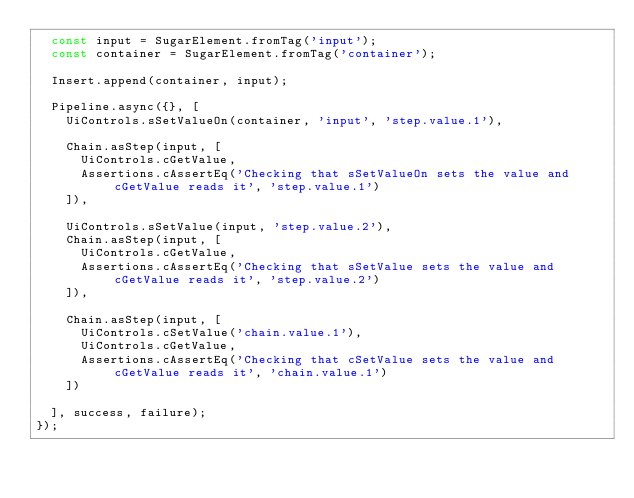Convert code to text. <code><loc_0><loc_0><loc_500><loc_500><_TypeScript_>  const input = SugarElement.fromTag('input');
  const container = SugarElement.fromTag('container');

  Insert.append(container, input);

  Pipeline.async({}, [
    UiControls.sSetValueOn(container, 'input', 'step.value.1'),

    Chain.asStep(input, [
      UiControls.cGetValue,
      Assertions.cAssertEq('Checking that sSetValueOn sets the value and cGetValue reads it', 'step.value.1')
    ]),

    UiControls.sSetValue(input, 'step.value.2'),
    Chain.asStep(input, [
      UiControls.cGetValue,
      Assertions.cAssertEq('Checking that sSetValue sets the value and cGetValue reads it', 'step.value.2')
    ]),

    Chain.asStep(input, [
      UiControls.cSetValue('chain.value.1'),
      UiControls.cGetValue,
      Assertions.cAssertEq('Checking that cSetValue sets the value and cGetValue reads it', 'chain.value.1')
    ])

  ], success, failure);
});
</code> 